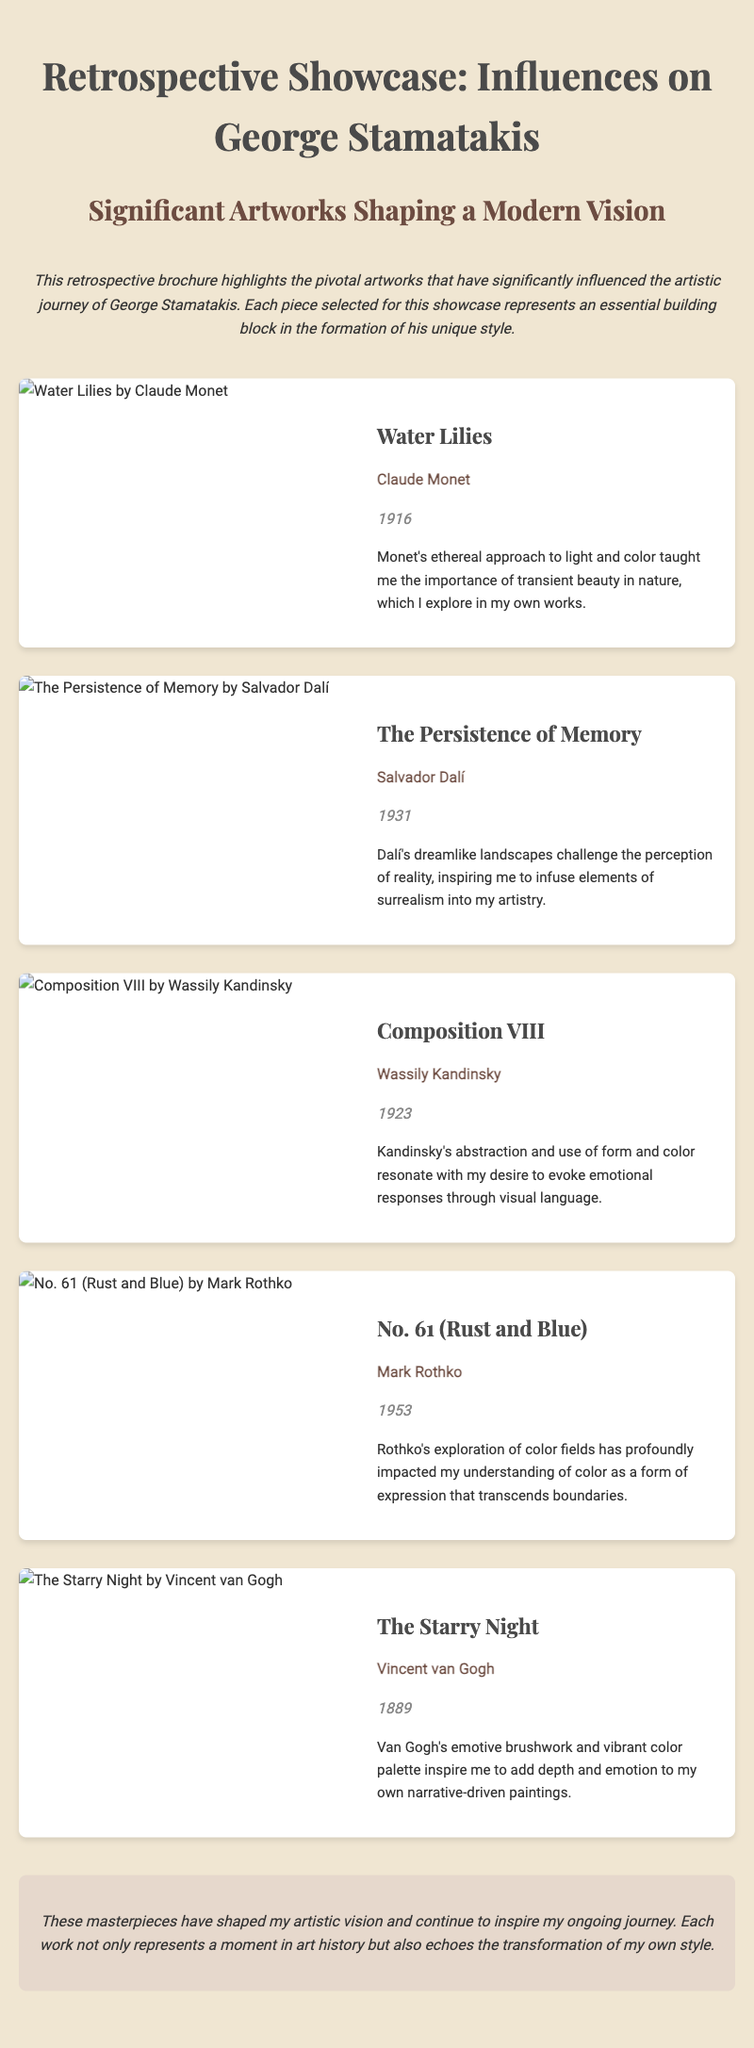What is the title of the brochure? The title of the brochure is prominently displayed at the top of the document.
Answer: Retrospective Showcase: Influences on George Stamatakis Who is the artist of "Water Lilies"? The artist of "Water Lilies" is mentioned in the artwork section.
Answer: Claude Monet In what year was "The Starry Night" created? The year "The Starry Night" was created is specified in the document next to the artwork title.
Answer: 1889 What is the main theme of the retrospective showcase? The theme is summarized in the description at the beginning of the document.
Answer: Significant artworks shaping a modern vision Which artist is associated with the artwork "No. 61 (Rust and Blue)"? The artist connected with "No. 61 (Rust and Blue)" is presented within the artwork's details.
Answer: Mark Rothko What does George Stamatakis claim to explore in his own work? The document specifies what Stamatakis explores in his art in the statements beneath each artwork.
Answer: Transient beauty in nature Which artwork is mentioned as having inspired elements of surrealism? The artwork that inspired surrealism is noted in the statement section related to that piece.
Answer: The Persistence of Memory What style does Kandinsky's "Composition VIII" represent? The style represented by Kandinsky's artwork is explained in the context of emotional evocation.
Answer: Abstraction 